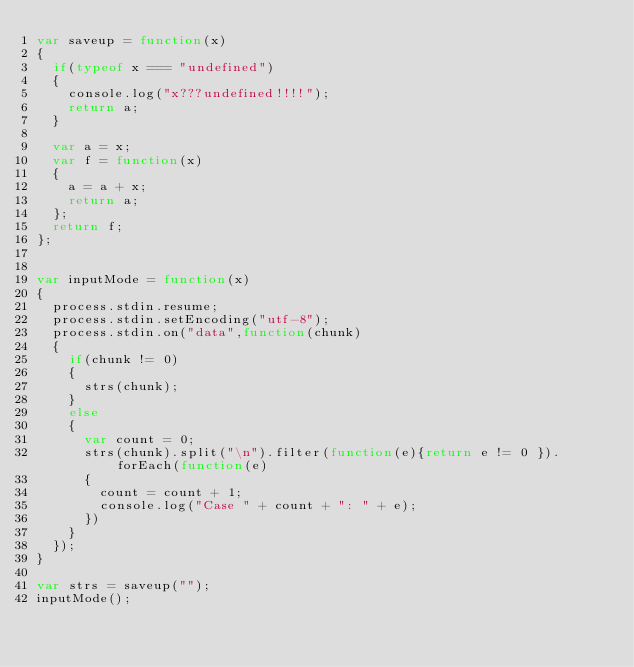Convert code to text. <code><loc_0><loc_0><loc_500><loc_500><_JavaScript_>var saveup = function(x)
{
  if(typeof x === "undefined")
  {
    console.log("x???undefined!!!!");
    return a;
  }

  var a = x;
  var f = function(x)
  {
    a = a + x;
    return a;
  };
  return f;
};


var inputMode = function(x)
{
  process.stdin.resume;
  process.stdin.setEncoding("utf-8");
  process.stdin.on("data",function(chunk)
  {
    if(chunk != 0)
    {
      strs(chunk);
    }
    else
    {
      var count = 0;
      strs(chunk).split("\n").filter(function(e){return e != 0 }).forEach(function(e)
      {
        count = count + 1;
        console.log("Case " + count + ": " + e);
      })
    }
  });
}

var strs = saveup("");
inputMode();</code> 